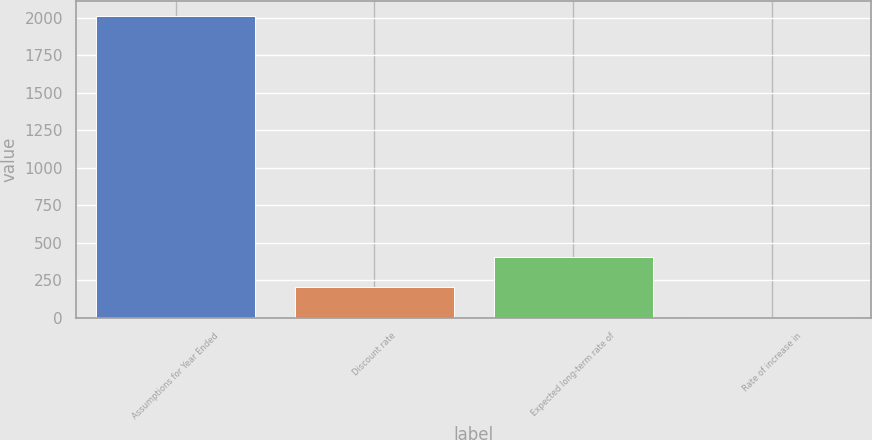Convert chart to OTSL. <chart><loc_0><loc_0><loc_500><loc_500><bar_chart><fcel>Assumptions for Year Ended<fcel>Discount rate<fcel>Expected long-term rate of<fcel>Rate of increase in<nl><fcel>2012<fcel>204.59<fcel>405.41<fcel>3.77<nl></chart> 